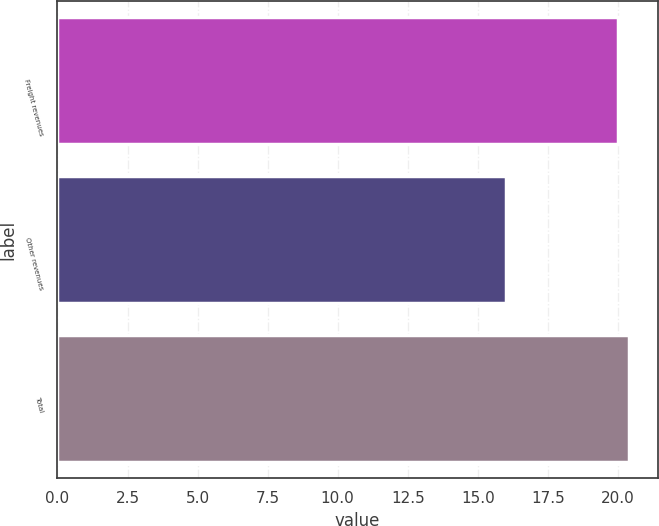Convert chart. <chart><loc_0><loc_0><loc_500><loc_500><bar_chart><fcel>Freight revenues<fcel>Other revenues<fcel>Total<nl><fcel>20<fcel>16<fcel>20.4<nl></chart> 